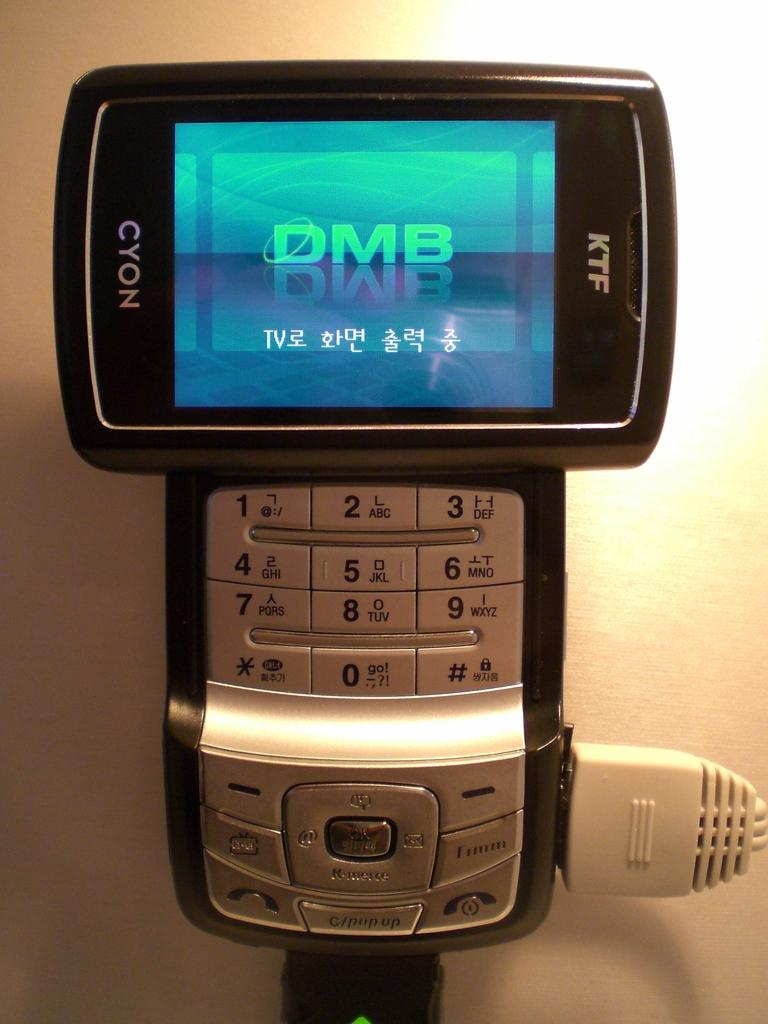<image>
Render a clear and concise summary of the photo. A Cyon KTF scanner has DMB on its led screen. 